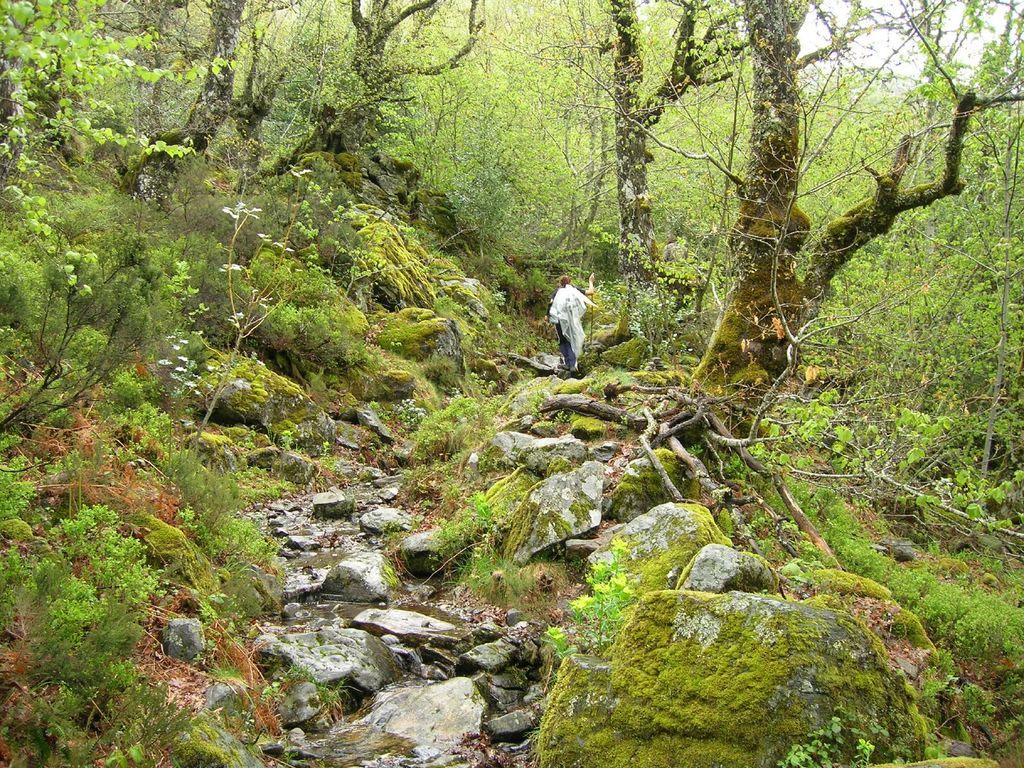What is the main subject of the image? There is a person standing in the center of the image. What is the person standing on? The person is standing on the surface of the grass. What can be seen in front of the person? There are rocks and plants in front of the image. What is visible in the background of the image? There are trees and the sky in the background of the image. What type of linen is being used to cover the rocks in the image? There is no linen present in the image, and the rocks are not covered. What is the mass of the person standing in the image? The mass of the person cannot be determined from the image alone. 